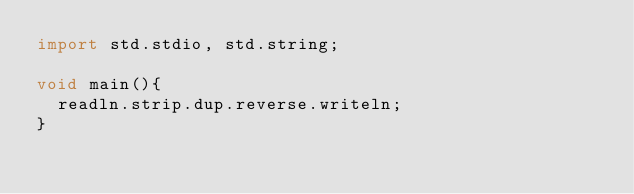Convert code to text. <code><loc_0><loc_0><loc_500><loc_500><_D_>import std.stdio, std.string;

void main(){
  readln.strip.dup.reverse.writeln;
}</code> 